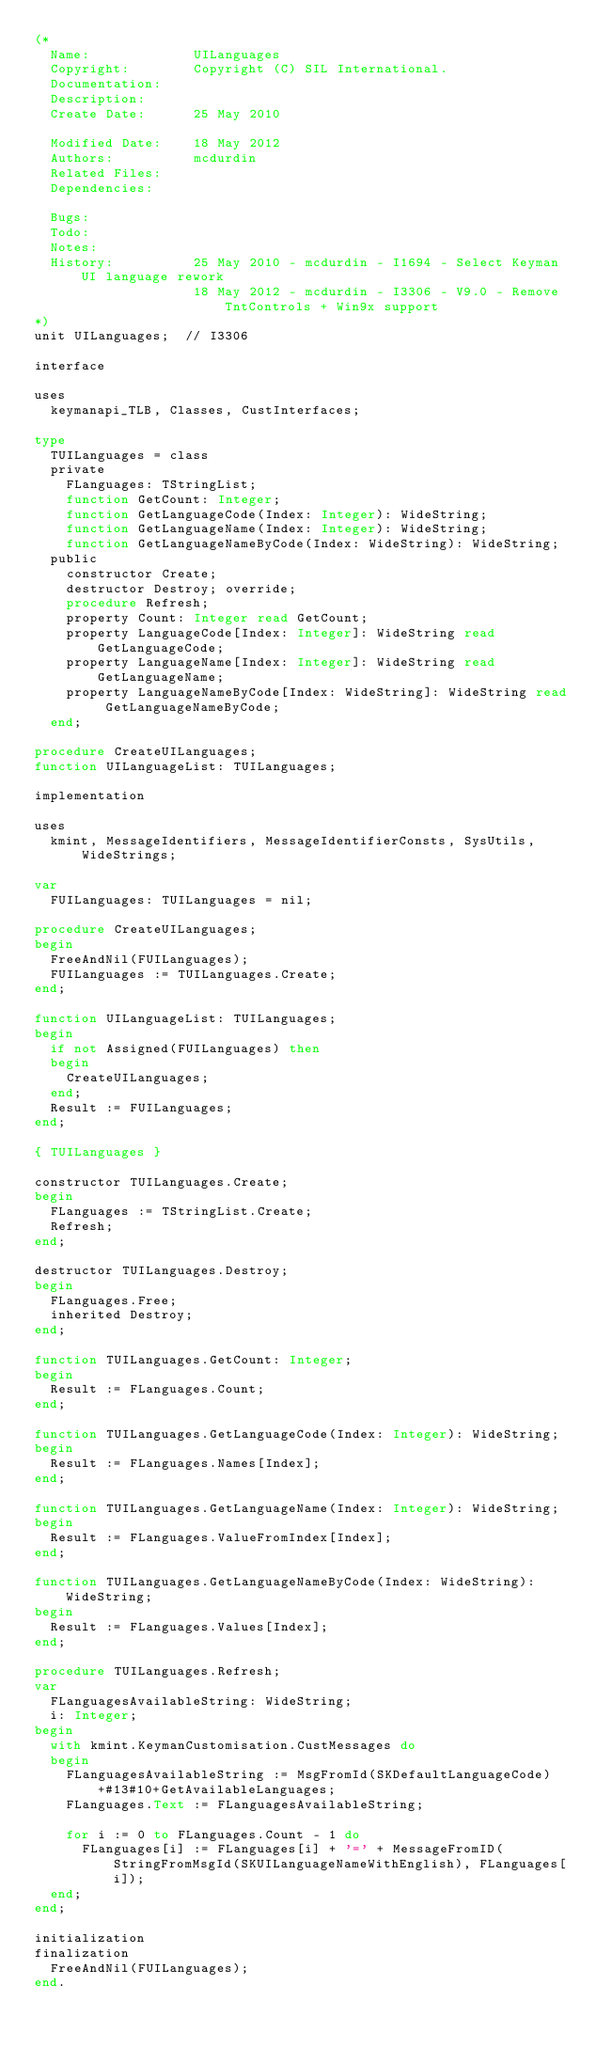Convert code to text. <code><loc_0><loc_0><loc_500><loc_500><_Pascal_>(*
  Name:             UILanguages
  Copyright:        Copyright (C) SIL International.
  Documentation:    
  Description:      
  Create Date:      25 May 2010

  Modified Date:    18 May 2012
  Authors:          mcdurdin
  Related Files:    
  Dependencies:     

  Bugs:             
  Todo:             
  Notes:            
  History:          25 May 2010 - mcdurdin - I1694 - Select Keyman UI language rework
                    18 May 2012 - mcdurdin - I3306 - V9.0 - Remove TntControls + Win9x support
*)
unit UILanguages;  // I3306

interface

uses
  keymanapi_TLB, Classes, CustInterfaces;

type
  TUILanguages = class
  private
    FLanguages: TStringList;
    function GetCount: Integer;
    function GetLanguageCode(Index: Integer): WideString;
    function GetLanguageName(Index: Integer): WideString;
    function GetLanguageNameByCode(Index: WideString): WideString;
  public
    constructor Create;
    destructor Destroy; override;
    procedure Refresh;
    property Count: Integer read GetCount;
    property LanguageCode[Index: Integer]: WideString read GetLanguageCode;
    property LanguageName[Index: Integer]: WideString read GetLanguageName;
    property LanguageNameByCode[Index: WideString]: WideString read GetLanguageNameByCode;
  end;

procedure CreateUILanguages;
function UILanguageList: TUILanguages;

implementation

uses
  kmint, MessageIdentifiers, MessageIdentifierConsts, SysUtils, WideStrings;

var
  FUILanguages: TUILanguages = nil;

procedure CreateUILanguages;
begin
  FreeAndNil(FUILanguages);
  FUILanguages := TUILanguages.Create;
end;

function UILanguageList: TUILanguages;
begin
  if not Assigned(FUILanguages) then
  begin
    CreateUILanguages;
  end;
  Result := FUILanguages;
end;

{ TUILanguages }

constructor TUILanguages.Create;
begin
  FLanguages := TStringList.Create;
  Refresh;
end;

destructor TUILanguages.Destroy;
begin
  FLanguages.Free;
  inherited Destroy;
end;

function TUILanguages.GetCount: Integer;
begin
  Result := FLanguages.Count;
end;

function TUILanguages.GetLanguageCode(Index: Integer): WideString;
begin
  Result := FLanguages.Names[Index];
end;

function TUILanguages.GetLanguageName(Index: Integer): WideString;
begin
  Result := FLanguages.ValueFromIndex[Index];
end;

function TUILanguages.GetLanguageNameByCode(Index: WideString): WideString;
begin
  Result := FLanguages.Values[Index];
end;

procedure TUILanguages.Refresh;
var
  FLanguagesAvailableString: WideString;
  i: Integer;
begin
  with kmint.KeymanCustomisation.CustMessages do
  begin
    FLanguagesAvailableString := MsgFromId(SKDefaultLanguageCode)+#13#10+GetAvailableLanguages;
    FLanguages.Text := FLanguagesAvailableString;

    for i := 0 to FLanguages.Count - 1 do
      FLanguages[i] := FLanguages[i] + '=' + MessageFromID(StringFromMsgId(SKUILanguageNameWithEnglish), FLanguages[i]);
  end;
end;

initialization
finalization
  FreeAndNil(FUILanguages);
end.
</code> 